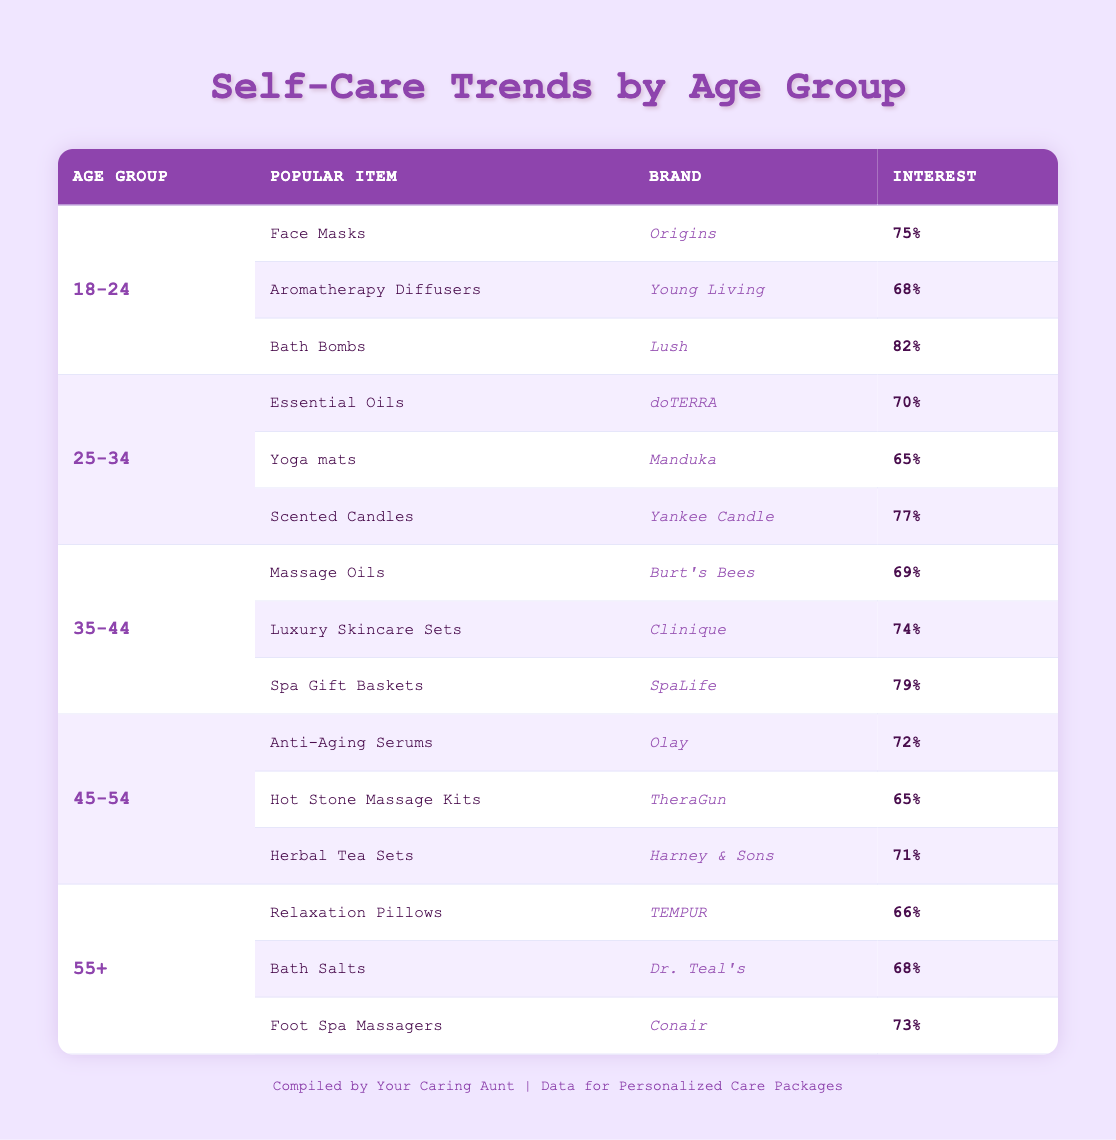What self-care item has the highest percentage interest among the age group 18-24? According to the table, in the age group 18-24, the item with the highest percentage interest is "Bath Bombs" with 82%.
Answer: Bath Bombs Which age group shows the lowest interest in self-care items among all listed? From the data, the age group 55+ has the lowest percentage interest for the popular items listed, with "Relaxation Pillows" at 66%.
Answer: 55+ What is the average percentage interest for the popular items in the age group 45-54? The items are "Anti-Aging Serums" (72%), "Hot Stone Massage Kits" (65%), and "Herbal Tea Sets" (71%). The sum of these percentages is 72 + 65 + 71 = 208. There are 3 items, so the average is 208/3 = 69.33.
Answer: 69.33 Is it true that "Yoga mats" have a higher percentage interest than "Foot Spa Massagers"? The percentage interest for "Yoga mats" is 65%, while for "Foot Spa Massagers," it is 73%. Since 65% is less than 73%, the statement is false.
Answer: No Which self-care items have more than 70% interest in the age group 35-44? In the age group 35-44, the items with more than 70% interest are "Luxury Skincare Sets" (74%) and "Spa Gift Baskets" (79%).
Answer: Luxury Skincare Sets and Spa Gift Baskets What is the difference in percentage interest between "Aromatherapy Diffusers" and "Scented Candles"? "Aromatherapy Diffusers" have 68% interest, while "Scented Candles" have 77%. The difference is 77 - 68 = 9%.
Answer: 9% Which brand appears most frequently across the different age groups? After reviewing the table, "Lush" appears only once in the age group 18-24 for "Bath Bombs," making it not the most frequent. Each brand appears once in their respective age groups, hence no brand stands out by frequency.
Answer: None What is the highest percentage interest for any item in the age group 25-34? In the age group 25-34, "Scented Candles" has the highest interest at 77%.
Answer: 77% 